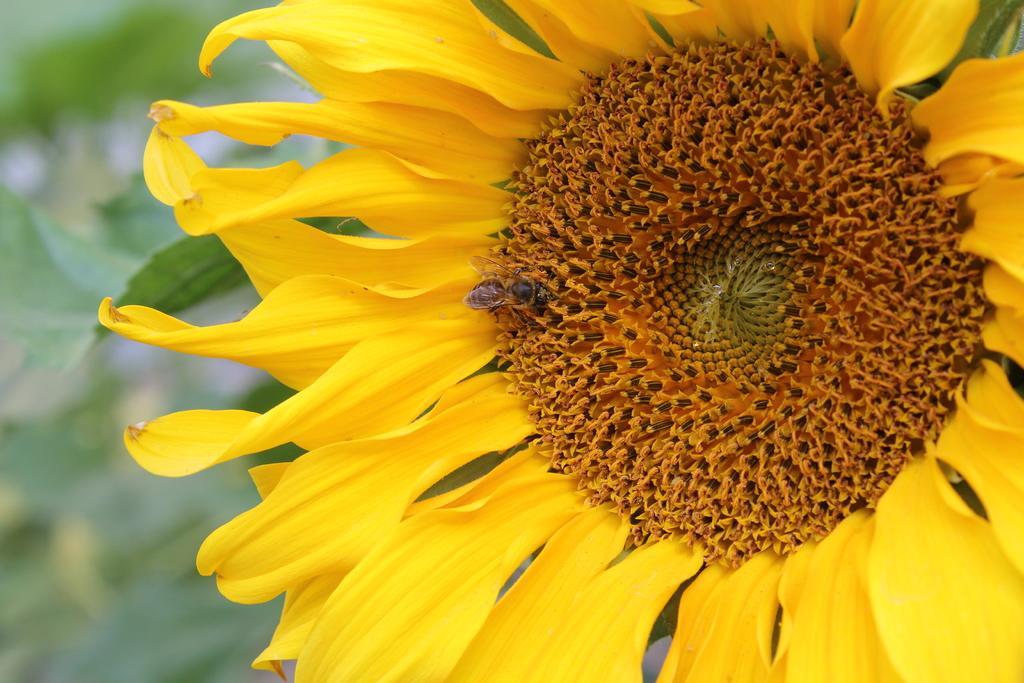Can you describe this image briefly? In this image we can see a fly on the sunflower. 